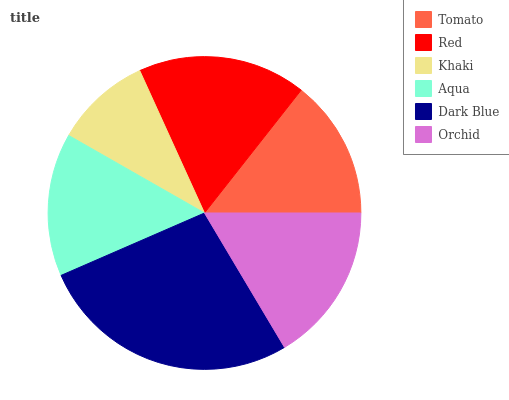Is Khaki the minimum?
Answer yes or no. Yes. Is Dark Blue the maximum?
Answer yes or no. Yes. Is Red the minimum?
Answer yes or no. No. Is Red the maximum?
Answer yes or no. No. Is Red greater than Tomato?
Answer yes or no. Yes. Is Tomato less than Red?
Answer yes or no. Yes. Is Tomato greater than Red?
Answer yes or no. No. Is Red less than Tomato?
Answer yes or no. No. Is Orchid the high median?
Answer yes or no. Yes. Is Aqua the low median?
Answer yes or no. Yes. Is Red the high median?
Answer yes or no. No. Is Dark Blue the low median?
Answer yes or no. No. 